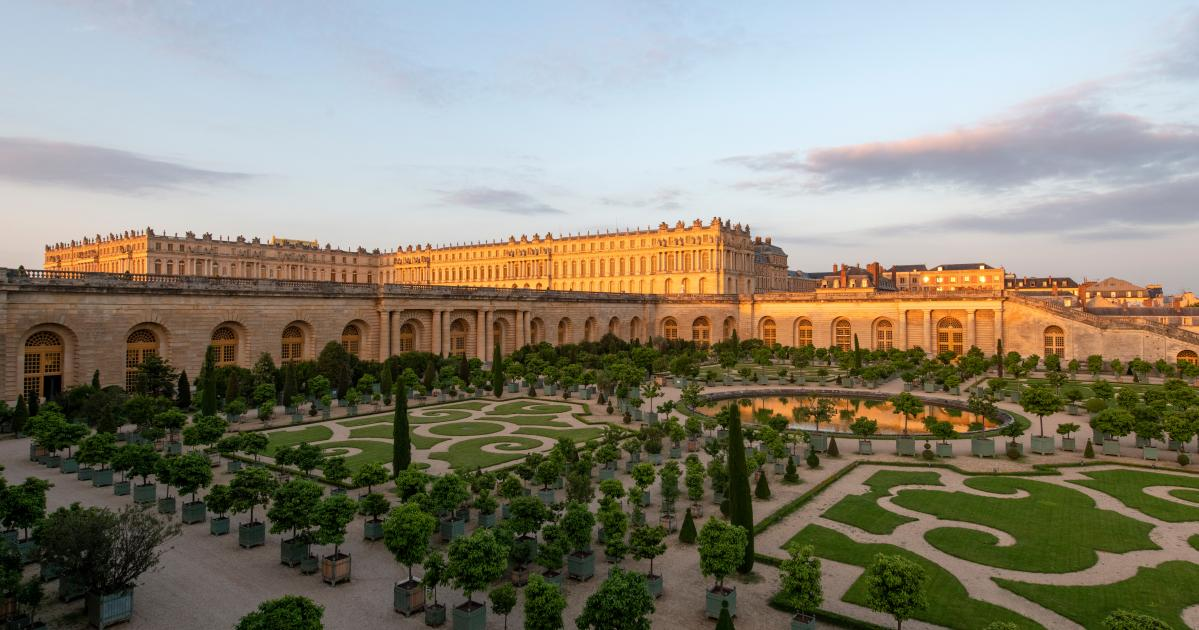Can you describe a typical day in the life of a royal who lived in this palace? A typical day for a royal living in the Palace of Versailles would be marked by opulence and ritual. The day begins with the grand lever (rising ceremony), attended by nobles who assist and observe as the royal prepares for the day. Mornings are often filled with meetings and audiences in lavishly adorned rooms, where vital state decisions are made. Lunchtime is a grand affair, with elaborate dishes served in the resplendent dining halls. Afternoons might include leisurely strolls through the impeccably kept gardens, socializing with courtiers, or engaging in cultural activities like theater or concerts. Evenings are marked by elaborate banquets and balls, where the glittering candlelight and shimmering gowns create an atmosphere of refined splendor. Every moment is woven with ceremony and elegance, befitting the grandeur of the palace. 